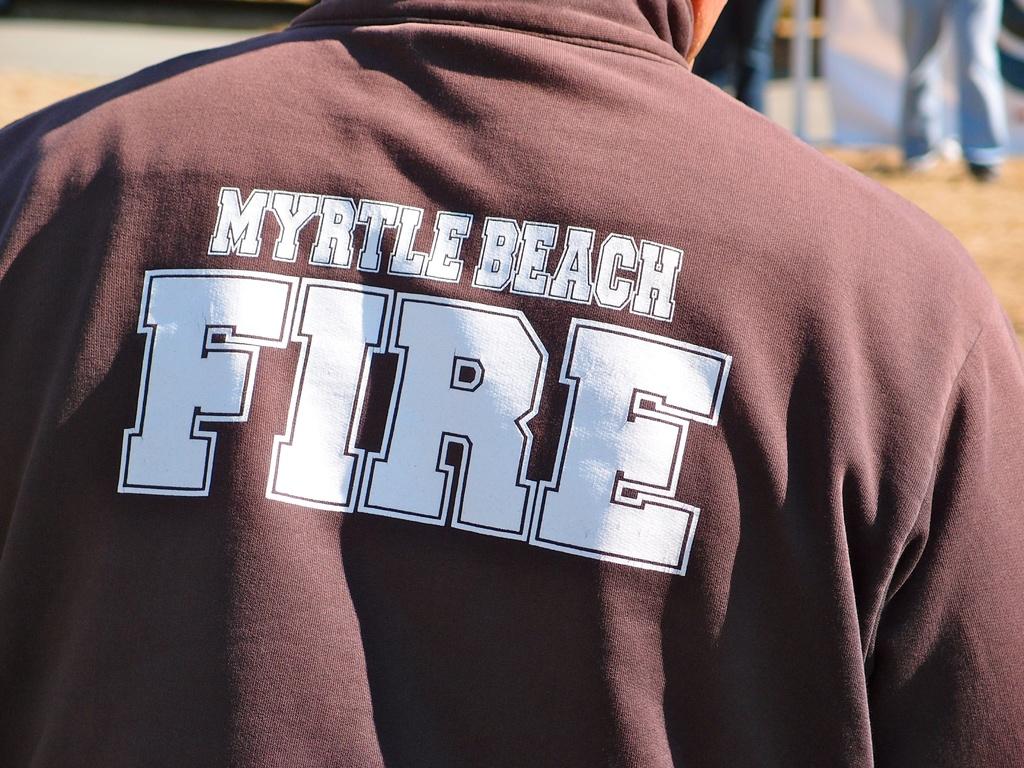Is he from myrtle beach?
Your answer should be compact. Yes. What type of hot thing is written on the back of the mans shirt?
Ensure brevity in your answer.  Fire. 